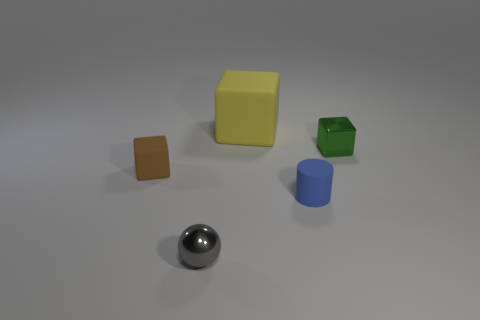Add 5 gray spheres. How many objects exist? 10 Subtract all small yellow blocks. Subtract all yellow matte objects. How many objects are left? 4 Add 3 small green cubes. How many small green cubes are left? 4 Add 4 small blue cylinders. How many small blue cylinders exist? 5 Subtract 0 cyan cylinders. How many objects are left? 5 Subtract all cubes. How many objects are left? 2 